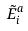<formula> <loc_0><loc_0><loc_500><loc_500>\tilde { E } _ { i } ^ { a }</formula> 